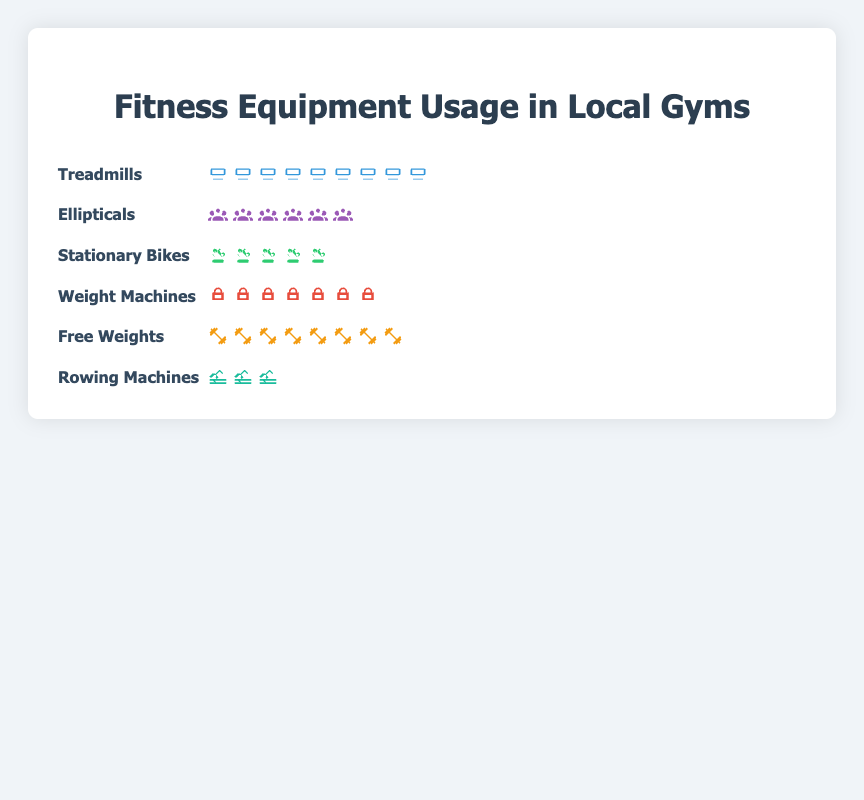What type of equipment has the highest usage in local gyms? The plot shows different types of fitness equipment with their usage in icons. The equipment with the most icons is Treadmills, indicating the highest usage.
Answer: Treadmills Which two types of equipment have a usage difference of 5? By examining the number of icons, Free Weights have 8 icons, and Weight Machines have 7 icons. The difference is 1, which is not the answer. Treadmills have 9 icons, and Weight Machines have 7 icons. The difference here is 2. The correct comparison is between Ellipticals (6 icons) and Stationary Bikes (5 icons) where the difference is 1.
Answer: Ellipticals and Stationary Bikes How many icons are displayed in total for all equipment combined? Sum up all the icons from each equipment type: Treadmills (9) + Ellipticals (6) + Stationary Bikes (5) + Weight Machines (7) + Free Weights (8) + Rowing Machines (3). Therefore, the total number of icons is 38.
Answer: 38 Which equipment type ranks third in terms of usage? By counting the number of icons from highest to lowest: Treadmills (9), Free Weights (8), Weight Machines (7). Hence, Weight Machines rank third.
Answer: Weight Machines Are there more icons for Free Weights or Ellipticals, and by how many? Free Weights have 8 icons, while Ellipticals have 6 icons. The difference is 2 icons.
Answer: Free Weights by 2 Which two equipment types have an equal number of icons? The plot shows that no two equipment types have the same number of icons, so no types have an equal number of icons.
Answer: None What is the total usage of Treadmills, Ellipticals, and Stationary Bikes combined? Sum up the number of icons for Treadmills (9), Ellipticals (6), and Stationary Bikes (5). The total is 9 + 6 + 5 = 20 icons.
Answer: 20 If we combine the usage of Weight Machines and Free Weights, what is their combined usage in icons? Sum up the number of icons for Weight Machines (7) and Free Weights (8). The combined usage is 7 + 8 = 15 icons.
Answer: 15 What is the average number of icons per equipment type? Calculate the total number of icons (38) and divide by the number of equipment types (6). The average is 38 / 6 ≈ 6.33 icons.
Answer: ~6.33 